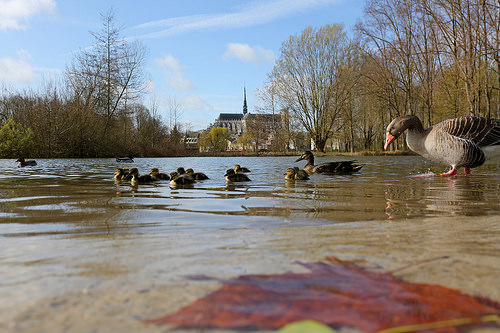<image>
Can you confirm if the duck is next to the ducklings? Yes. The duck is positioned adjacent to the ducklings, located nearby in the same general area. 